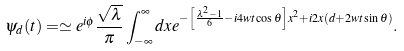<formula> <loc_0><loc_0><loc_500><loc_500>\psi _ { d } ( t ) = \simeq e ^ { i \phi } \frac { \sqrt { \lambda } } { \pi } \int ^ { \infty } _ { - \infty } d x e ^ { - \left [ \frac { \lambda ^ { 2 } - 1 } { 6 } - i 4 w t \cos { \theta } \right ] x ^ { 2 } + i 2 x ( d + 2 w t \sin \theta ) } .</formula> 